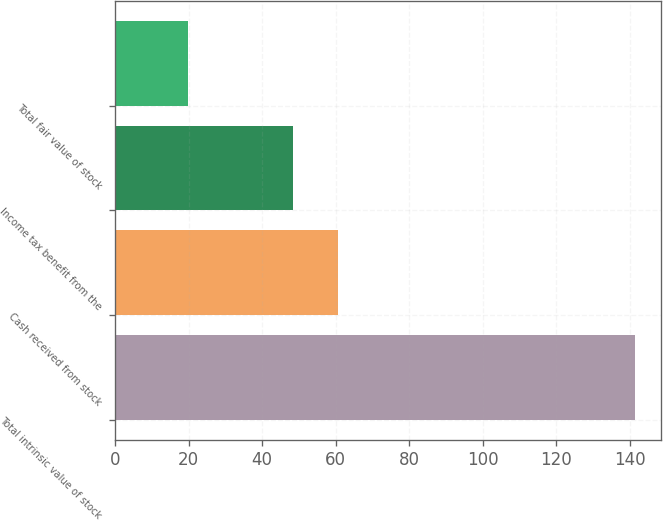<chart> <loc_0><loc_0><loc_500><loc_500><bar_chart><fcel>Total intrinsic value of stock<fcel>Cash received from stock<fcel>Income tax benefit from the<fcel>Total fair value of stock<nl><fcel>141.3<fcel>60.65<fcel>48.5<fcel>19.8<nl></chart> 